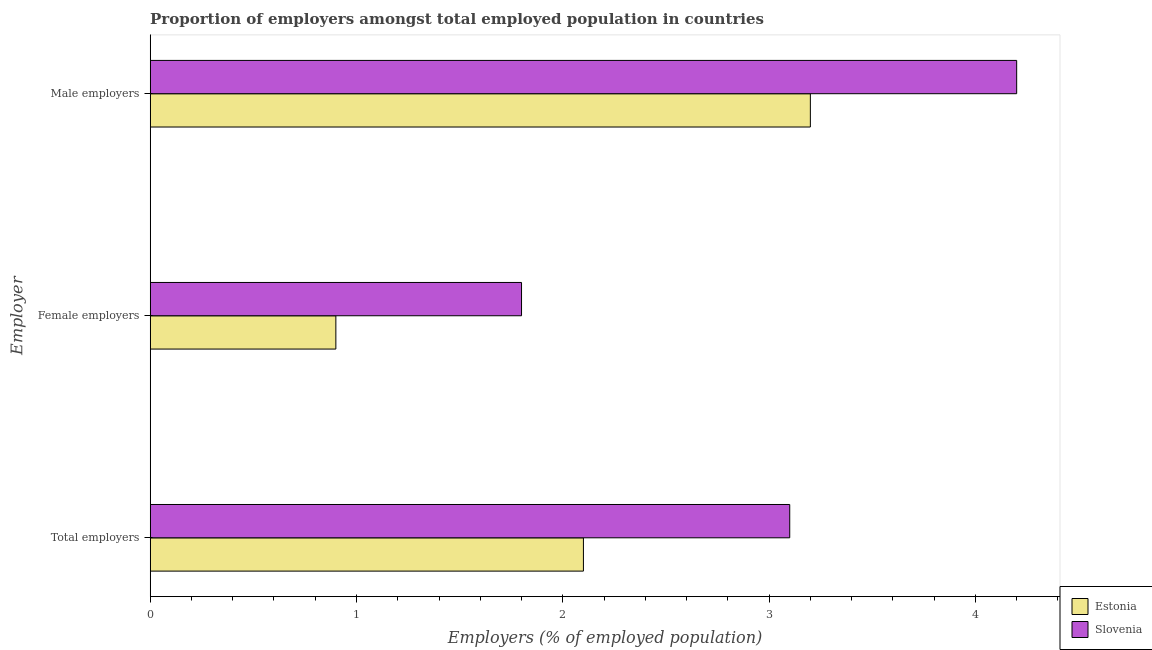How many groups of bars are there?
Provide a succinct answer. 3. Are the number of bars on each tick of the Y-axis equal?
Offer a very short reply. Yes. How many bars are there on the 2nd tick from the top?
Ensure brevity in your answer.  2. How many bars are there on the 3rd tick from the bottom?
Provide a short and direct response. 2. What is the label of the 1st group of bars from the top?
Provide a succinct answer. Male employers. What is the percentage of female employers in Estonia?
Your answer should be compact. 0.9. Across all countries, what is the maximum percentage of female employers?
Keep it short and to the point. 1.8. Across all countries, what is the minimum percentage of female employers?
Provide a succinct answer. 0.9. In which country was the percentage of total employers maximum?
Provide a succinct answer. Slovenia. In which country was the percentage of female employers minimum?
Offer a very short reply. Estonia. What is the total percentage of total employers in the graph?
Your answer should be compact. 5.2. What is the difference between the percentage of female employers in Estonia and that in Slovenia?
Your answer should be very brief. -0.9. What is the difference between the percentage of total employers in Estonia and the percentage of female employers in Slovenia?
Ensure brevity in your answer.  0.3. What is the average percentage of total employers per country?
Your answer should be compact. 2.6. What is the difference between the percentage of female employers and percentage of male employers in Slovenia?
Give a very brief answer. -2.4. What is the ratio of the percentage of female employers in Estonia to that in Slovenia?
Offer a very short reply. 0.5. Is the difference between the percentage of total employers in Estonia and Slovenia greater than the difference between the percentage of female employers in Estonia and Slovenia?
Your response must be concise. No. What is the difference between the highest and the lowest percentage of total employers?
Offer a very short reply. 1. In how many countries, is the percentage of total employers greater than the average percentage of total employers taken over all countries?
Offer a very short reply. 1. What does the 2nd bar from the top in Total employers represents?
Ensure brevity in your answer.  Estonia. What does the 1st bar from the bottom in Female employers represents?
Keep it short and to the point. Estonia. Are all the bars in the graph horizontal?
Offer a terse response. Yes. How many countries are there in the graph?
Make the answer very short. 2. What is the difference between two consecutive major ticks on the X-axis?
Offer a terse response. 1. Are the values on the major ticks of X-axis written in scientific E-notation?
Offer a terse response. No. Where does the legend appear in the graph?
Offer a terse response. Bottom right. How are the legend labels stacked?
Make the answer very short. Vertical. What is the title of the graph?
Offer a very short reply. Proportion of employers amongst total employed population in countries. What is the label or title of the X-axis?
Ensure brevity in your answer.  Employers (% of employed population). What is the label or title of the Y-axis?
Your response must be concise. Employer. What is the Employers (% of employed population) of Estonia in Total employers?
Give a very brief answer. 2.1. What is the Employers (% of employed population) of Slovenia in Total employers?
Provide a succinct answer. 3.1. What is the Employers (% of employed population) of Estonia in Female employers?
Offer a very short reply. 0.9. What is the Employers (% of employed population) in Slovenia in Female employers?
Make the answer very short. 1.8. What is the Employers (% of employed population) of Estonia in Male employers?
Offer a very short reply. 3.2. What is the Employers (% of employed population) in Slovenia in Male employers?
Make the answer very short. 4.2. Across all Employer, what is the maximum Employers (% of employed population) of Estonia?
Provide a succinct answer. 3.2. Across all Employer, what is the maximum Employers (% of employed population) of Slovenia?
Offer a very short reply. 4.2. Across all Employer, what is the minimum Employers (% of employed population) of Estonia?
Offer a very short reply. 0.9. Across all Employer, what is the minimum Employers (% of employed population) in Slovenia?
Ensure brevity in your answer.  1.8. What is the total Employers (% of employed population) in Estonia in the graph?
Give a very brief answer. 6.2. What is the difference between the Employers (% of employed population) in Slovenia in Total employers and that in Female employers?
Provide a short and direct response. 1.3. What is the difference between the Employers (% of employed population) in Estonia in Total employers and that in Male employers?
Make the answer very short. -1.1. What is the difference between the Employers (% of employed population) of Slovenia in Total employers and that in Male employers?
Your response must be concise. -1.1. What is the difference between the Employers (% of employed population) of Estonia in Female employers and that in Male employers?
Provide a short and direct response. -2.3. What is the difference between the Employers (% of employed population) of Slovenia in Female employers and that in Male employers?
Provide a succinct answer. -2.4. What is the difference between the Employers (% of employed population) in Estonia in Total employers and the Employers (% of employed population) in Slovenia in Female employers?
Make the answer very short. 0.3. What is the average Employers (% of employed population) of Estonia per Employer?
Provide a succinct answer. 2.07. What is the average Employers (% of employed population) of Slovenia per Employer?
Keep it short and to the point. 3.03. What is the difference between the Employers (% of employed population) in Estonia and Employers (% of employed population) in Slovenia in Total employers?
Provide a short and direct response. -1. What is the difference between the Employers (% of employed population) in Estonia and Employers (% of employed population) in Slovenia in Male employers?
Your answer should be very brief. -1. What is the ratio of the Employers (% of employed population) of Estonia in Total employers to that in Female employers?
Your answer should be compact. 2.33. What is the ratio of the Employers (% of employed population) of Slovenia in Total employers to that in Female employers?
Your response must be concise. 1.72. What is the ratio of the Employers (% of employed population) of Estonia in Total employers to that in Male employers?
Provide a short and direct response. 0.66. What is the ratio of the Employers (% of employed population) of Slovenia in Total employers to that in Male employers?
Offer a terse response. 0.74. What is the ratio of the Employers (% of employed population) of Estonia in Female employers to that in Male employers?
Your response must be concise. 0.28. What is the ratio of the Employers (% of employed population) in Slovenia in Female employers to that in Male employers?
Provide a short and direct response. 0.43. What is the difference between the highest and the second highest Employers (% of employed population) of Slovenia?
Ensure brevity in your answer.  1.1. What is the difference between the highest and the lowest Employers (% of employed population) of Estonia?
Offer a terse response. 2.3. 